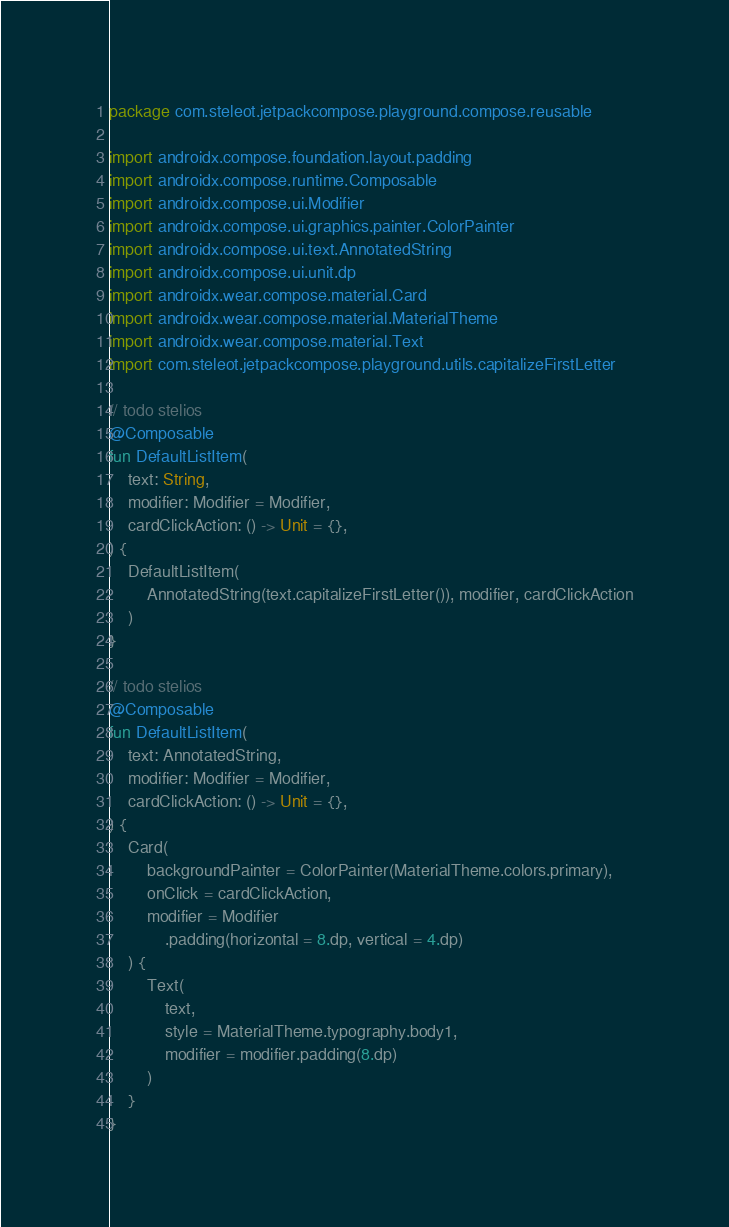<code> <loc_0><loc_0><loc_500><loc_500><_Kotlin_>package com.steleot.jetpackcompose.playground.compose.reusable

import androidx.compose.foundation.layout.padding
import androidx.compose.runtime.Composable
import androidx.compose.ui.Modifier
import androidx.compose.ui.graphics.painter.ColorPainter
import androidx.compose.ui.text.AnnotatedString
import androidx.compose.ui.unit.dp
import androidx.wear.compose.material.Card
import androidx.wear.compose.material.MaterialTheme
import androidx.wear.compose.material.Text
import com.steleot.jetpackcompose.playground.utils.capitalizeFirstLetter

// todo stelios
@Composable
fun DefaultListItem(
    text: String,
    modifier: Modifier = Modifier,
    cardClickAction: () -> Unit = {},
) {
    DefaultListItem(
        AnnotatedString(text.capitalizeFirstLetter()), modifier, cardClickAction
    )
}

// todo stelios
@Composable
fun DefaultListItem(
    text: AnnotatedString,
    modifier: Modifier = Modifier,
    cardClickAction: () -> Unit = {},
) {
    Card(
        backgroundPainter = ColorPainter(MaterialTheme.colors.primary),
        onClick = cardClickAction,
        modifier = Modifier
            .padding(horizontal = 8.dp, vertical = 4.dp)
    ) {
        Text(
            text,
            style = MaterialTheme.typography.body1,
            modifier = modifier.padding(8.dp)
        )
    }
}</code> 